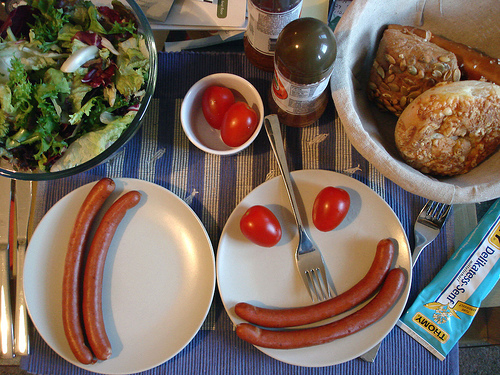<image>
Can you confirm if the spoon is on the plate? Yes. Looking at the image, I can see the spoon is positioned on top of the plate, with the plate providing support. Where is the tomato in relation to the fork? Is it on the fork? No. The tomato is not positioned on the fork. They may be near each other, but the tomato is not supported by or resting on top of the fork. 